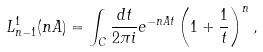Convert formula to latex. <formula><loc_0><loc_0><loc_500><loc_500>L _ { n - 1 } ^ { 1 } ( n A ) = \int _ { C } \frac { d t } { 2 \pi i } e ^ { - n A t } \left ( 1 + \frac { 1 } { t } \right ) ^ { n } ,</formula> 